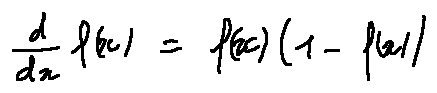Convert formula to latex. <formula><loc_0><loc_0><loc_500><loc_500>\frac { d } { d x } f ( x ) = f ( x ) ( 1 - f ( x ) )</formula> 